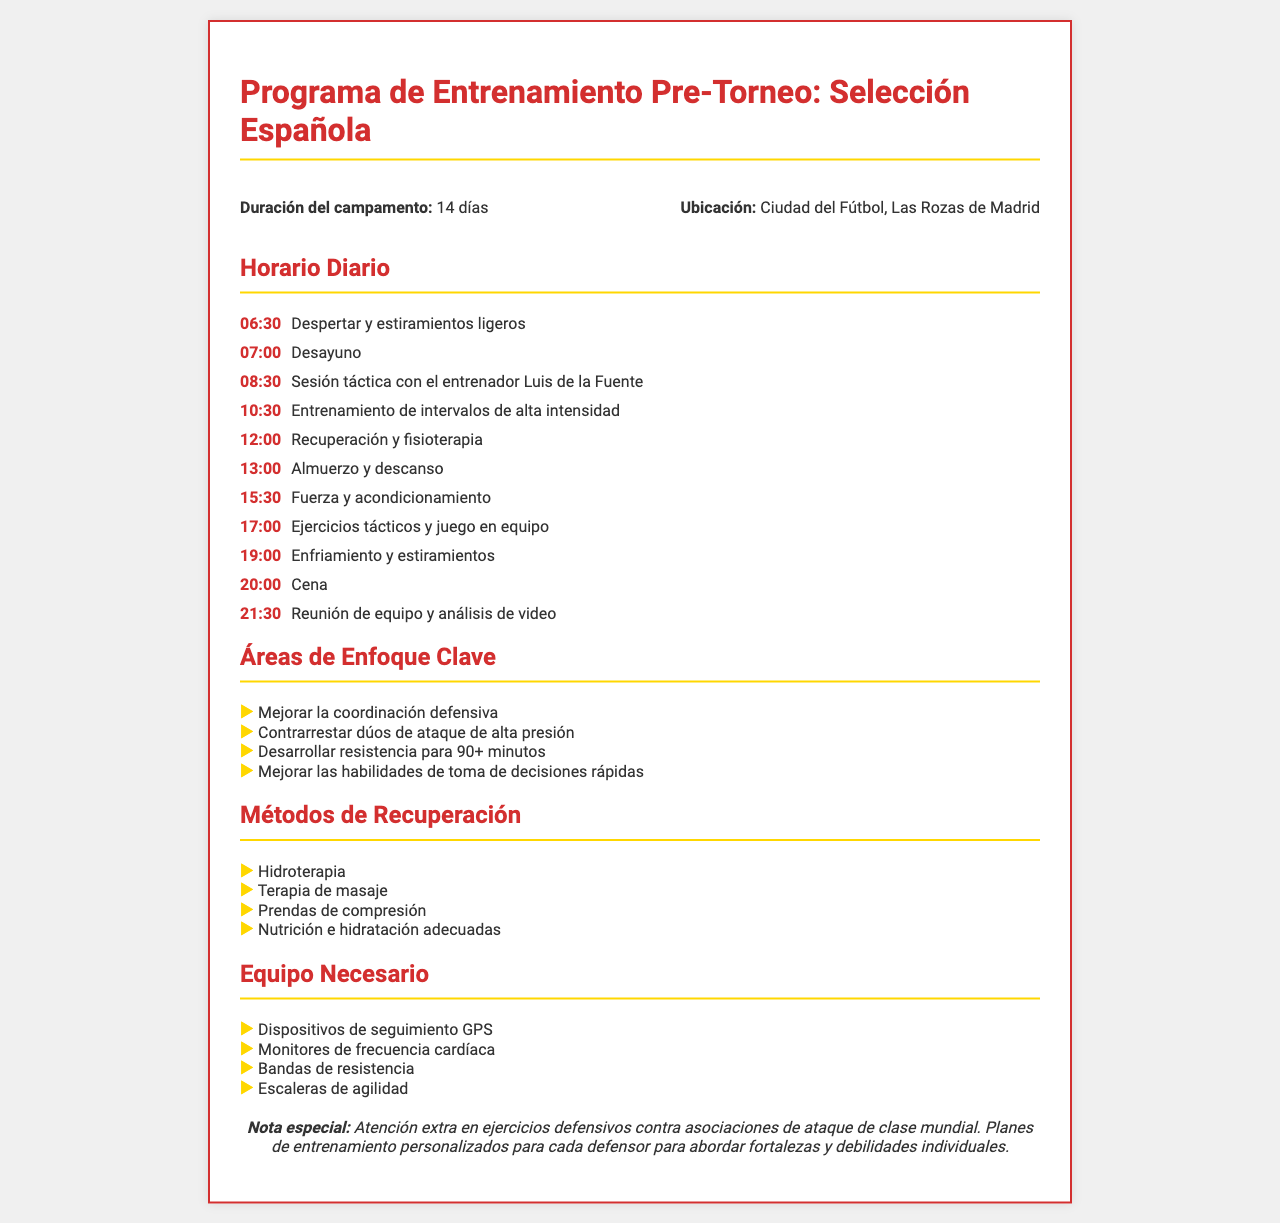¿Cuántos días dura el campamento? La duración del campamento es mencionada en el documento, que indica 14 días.
Answer: 14 días ¿Dónde se lleva a cabo el campamento? La ubicación del campamento está claramente especificada en el fax como Ciudad del Fútbol, Las Rozas de Madrid.
Answer: Ciudad del Fútbol, Las Rozas de Madrid ¿Quién es el entrenador mencionado durante la sesión táctica? El documento menciona específicamente al entrenador Luis de la Fuente durante la sesión táctica.
Answer: Luis de la Fuente ¿Cuál es un método de recuperación mencionado en el documento? En la sección de Métodos de Recuperación, se enumera Hidroterapia como uno de los métodos.
Answer: Hidroterapia ¿Cuál es una de las áreas de enfoque clave en el entrenamiento? Una de las áreas de enfoque clave listadas es mejorar la coordinación defensiva.
Answer: Mejorar la coordinación defensiva ¿Qué tipo de equipo se necesita para el campamento? Una de las piezas de equipo necesarias según el documento es Dispositivos de seguimiento GPS.
Answer: Dispositivos de seguimiento GPS ¿Cuál es el primer evento del horario diario? El primer evento del horario diario es despertar y estiramientos ligeros a las 06:30.
Answer: Despertar y estiramientos ligeros ¿Cuál es la nota especial en el documento? La nota especial enfatiza la atención extra en ejercicios defensivos contra asociaciones de ataque de clase mundial.
Answer: Atención extra en ejercicios defensivos contra asociaciones de ataque de clase mundial 